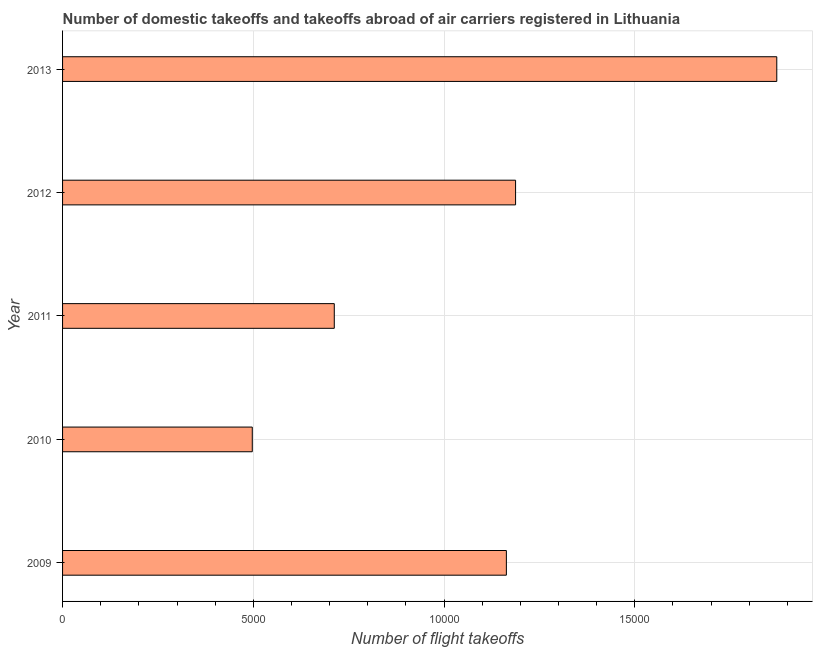Does the graph contain grids?
Provide a succinct answer. Yes. What is the title of the graph?
Your answer should be compact. Number of domestic takeoffs and takeoffs abroad of air carriers registered in Lithuania. What is the label or title of the X-axis?
Your response must be concise. Number of flight takeoffs. What is the number of flight takeoffs in 2010?
Keep it short and to the point. 4972.63. Across all years, what is the maximum number of flight takeoffs?
Offer a very short reply. 1.87e+04. Across all years, what is the minimum number of flight takeoffs?
Ensure brevity in your answer.  4972.63. In which year was the number of flight takeoffs minimum?
Keep it short and to the point. 2010. What is the sum of the number of flight takeoffs?
Make the answer very short. 5.43e+04. What is the difference between the number of flight takeoffs in 2009 and 2013?
Make the answer very short. -7087.54. What is the average number of flight takeoffs per year?
Provide a short and direct response. 1.09e+04. What is the median number of flight takeoffs?
Keep it short and to the point. 1.16e+04. Do a majority of the years between 2009 and 2011 (inclusive) have number of flight takeoffs greater than 6000 ?
Offer a very short reply. Yes. What is the ratio of the number of flight takeoffs in 2010 to that in 2013?
Keep it short and to the point. 0.27. Is the number of flight takeoffs in 2009 less than that in 2012?
Keep it short and to the point. Yes. What is the difference between the highest and the second highest number of flight takeoffs?
Offer a very short reply. 6846.54. Is the sum of the number of flight takeoffs in 2011 and 2012 greater than the maximum number of flight takeoffs across all years?
Make the answer very short. Yes. What is the difference between the highest and the lowest number of flight takeoffs?
Your response must be concise. 1.37e+04. In how many years, is the number of flight takeoffs greater than the average number of flight takeoffs taken over all years?
Offer a very short reply. 3. Are all the bars in the graph horizontal?
Your answer should be very brief. Yes. What is the difference between two consecutive major ticks on the X-axis?
Your answer should be very brief. 5000. What is the Number of flight takeoffs in 2009?
Your response must be concise. 1.16e+04. What is the Number of flight takeoffs of 2010?
Offer a terse response. 4972.63. What is the Number of flight takeoffs of 2011?
Provide a short and direct response. 7122. What is the Number of flight takeoffs of 2012?
Provide a short and direct response. 1.19e+04. What is the Number of flight takeoffs in 2013?
Offer a very short reply. 1.87e+04. What is the difference between the Number of flight takeoffs in 2009 and 2010?
Keep it short and to the point. 6660.37. What is the difference between the Number of flight takeoffs in 2009 and 2011?
Offer a very short reply. 4511. What is the difference between the Number of flight takeoffs in 2009 and 2012?
Make the answer very short. -241. What is the difference between the Number of flight takeoffs in 2009 and 2013?
Your answer should be compact. -7087.54. What is the difference between the Number of flight takeoffs in 2010 and 2011?
Make the answer very short. -2149.37. What is the difference between the Number of flight takeoffs in 2010 and 2012?
Your answer should be compact. -6901.37. What is the difference between the Number of flight takeoffs in 2010 and 2013?
Give a very brief answer. -1.37e+04. What is the difference between the Number of flight takeoffs in 2011 and 2012?
Give a very brief answer. -4752. What is the difference between the Number of flight takeoffs in 2011 and 2013?
Ensure brevity in your answer.  -1.16e+04. What is the difference between the Number of flight takeoffs in 2012 and 2013?
Offer a very short reply. -6846.54. What is the ratio of the Number of flight takeoffs in 2009 to that in 2010?
Your answer should be compact. 2.34. What is the ratio of the Number of flight takeoffs in 2009 to that in 2011?
Provide a short and direct response. 1.63. What is the ratio of the Number of flight takeoffs in 2009 to that in 2013?
Provide a short and direct response. 0.62. What is the ratio of the Number of flight takeoffs in 2010 to that in 2011?
Offer a terse response. 0.7. What is the ratio of the Number of flight takeoffs in 2010 to that in 2012?
Your answer should be compact. 0.42. What is the ratio of the Number of flight takeoffs in 2010 to that in 2013?
Your answer should be very brief. 0.27. What is the ratio of the Number of flight takeoffs in 2011 to that in 2013?
Your answer should be compact. 0.38. What is the ratio of the Number of flight takeoffs in 2012 to that in 2013?
Offer a terse response. 0.63. 